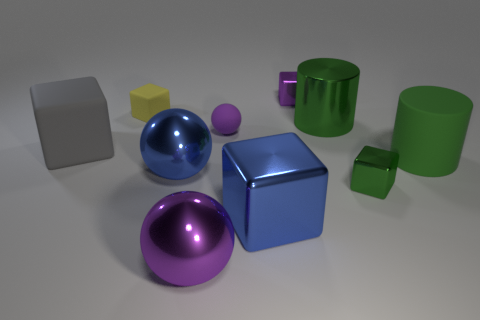Subtract 1 blocks. How many blocks are left? 4 Subtract all red cubes. Subtract all green balls. How many cubes are left? 5 Subtract all cylinders. How many objects are left? 8 Add 8 big purple metal spheres. How many big purple metal spheres are left? 9 Add 1 yellow rubber objects. How many yellow rubber objects exist? 2 Subtract 1 green blocks. How many objects are left? 9 Subtract all large metal blocks. Subtract all tiny purple shiny cubes. How many objects are left? 8 